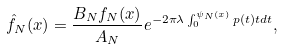<formula> <loc_0><loc_0><loc_500><loc_500>\hat { f } _ { N } ( x ) = \frac { B _ { N } f _ { N } ( x ) } { A _ { N } } e ^ { - 2 \pi \lambda \int _ { 0 } ^ { \psi _ { N } ( x ) } p ( t ) t d t } ,</formula> 